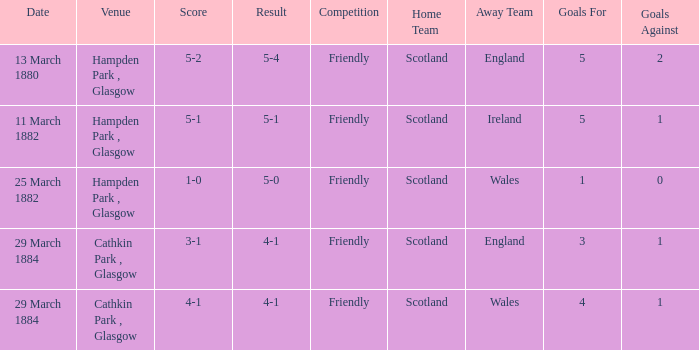Which item resulted in a score of 4-1? 3-1, 4-1. 